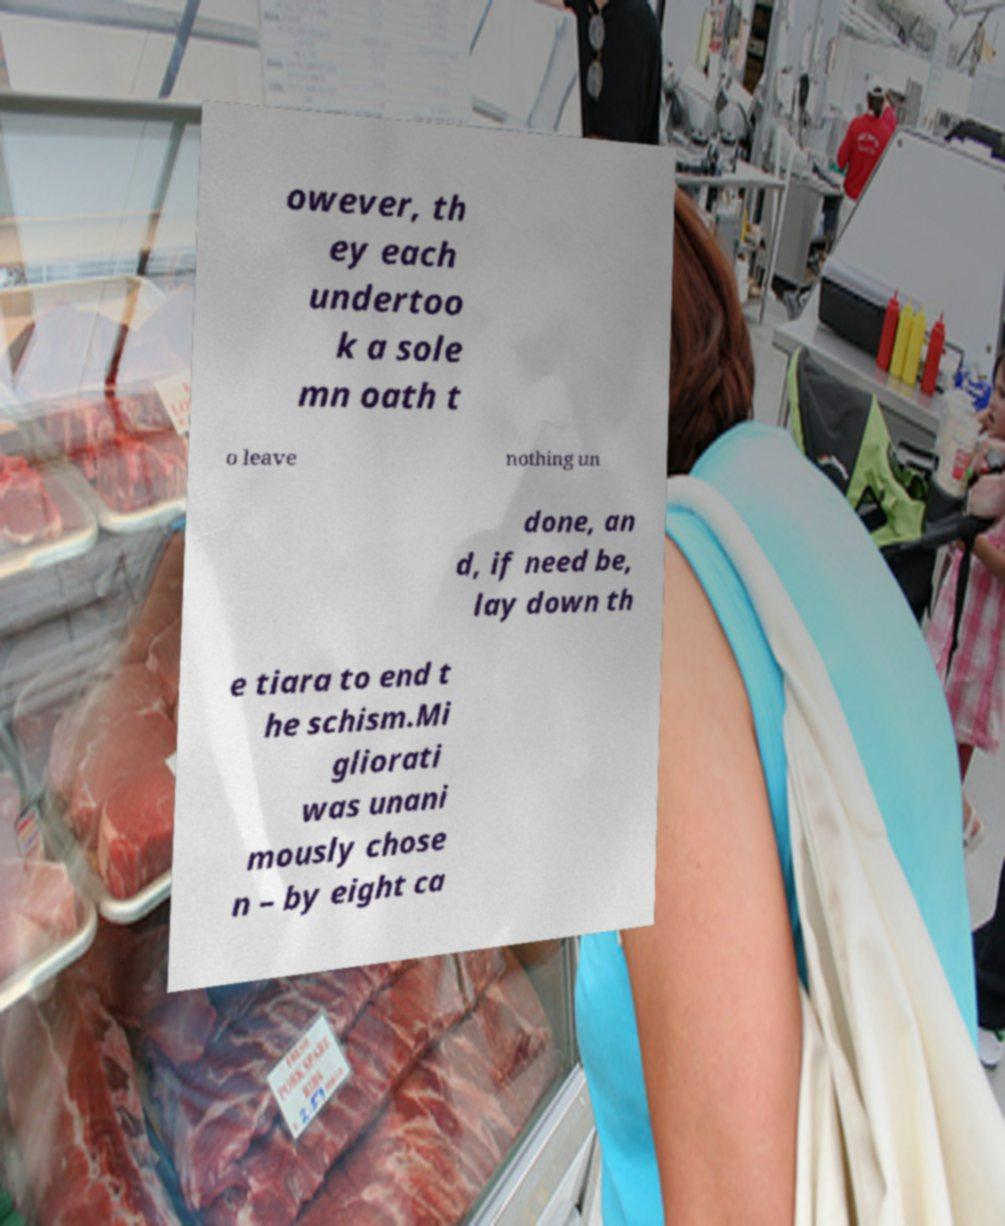Please identify and transcribe the text found in this image. owever, th ey each undertoo k a sole mn oath t o leave nothing un done, an d, if need be, lay down th e tiara to end t he schism.Mi gliorati was unani mously chose n – by eight ca 